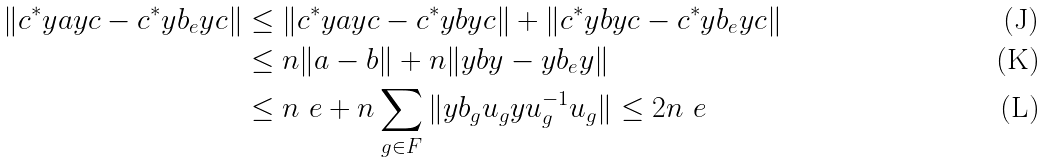Convert formula to latex. <formula><loc_0><loc_0><loc_500><loc_500>\| c ^ { * } y a y c - c ^ { * } y b _ { e } y c \| & \leq \| c ^ { * } y a y c - c ^ { * } y b y c \| + \| c ^ { * } y b y c - c ^ { * } y b _ { e } y c \| \\ & \leq n \| a - b \| + n \| y b y - y b _ { e } y \| \\ & \leq n \ e + n \sum _ { g \in F } \| y b _ { g } u _ { g } y u _ { g } ^ { - 1 } u _ { g } \| \leq 2 n \ e</formula> 